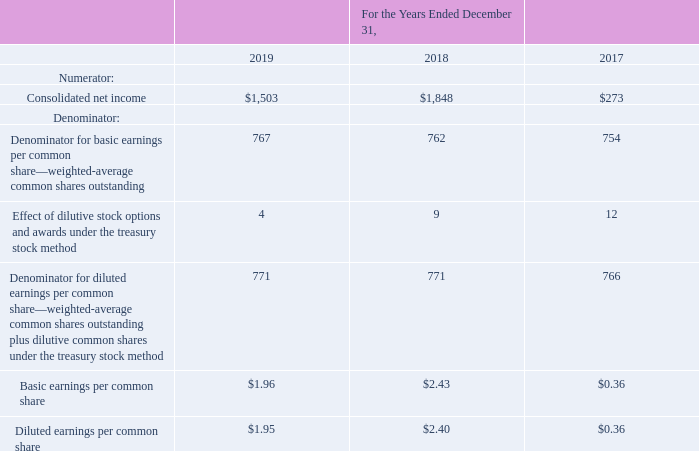20. Computation of Basic/Diluted Earnings Per Common Share
The following table sets forth the computation of basic and diluted earnings per common share (amounts in millions, except per share data):
The vesting of certain of our employee-related restricted stock units and options is contingent upon the satisfaction of predefined performance measures. The shares underlying these equity awards are included in the weighted-average dilutive common shares only if the performance measures are met as of the end of the reporting period. Additionally, potential common shares are not included in the denominator of the diluted earnings per common share calculation when the inclusion of such shares would be anti-dilutive.
What was the consolidated net income in 2018?
Answer scale should be: million. $1,848. What was the consolidated net income in 2019?
Answer scale should be: million. $1,503. What was the Basic earnings per common share in 2017? $0.36. What was the change in consolidated net income between 2018 and 2019?
Answer scale should be: million. $1,503-$1,848
Answer: -345. What was the change in diluted earnings per common share between 2018 and 2019? $1.95-$2.40
Answer: -0.45. What was the percentage change in basic earnings per common share between 2017 and 2018?
Answer scale should be: percent. ($2.43-$0.36)/$0.36
Answer: 575. 